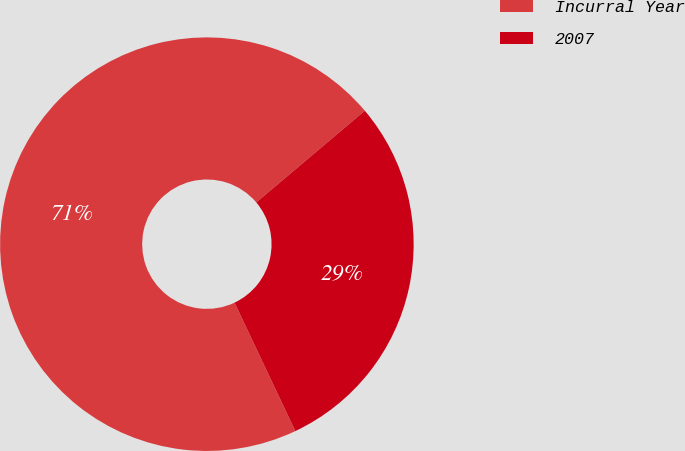Convert chart to OTSL. <chart><loc_0><loc_0><loc_500><loc_500><pie_chart><fcel>Incurral Year<fcel>2007<nl><fcel>70.87%<fcel>29.13%<nl></chart> 